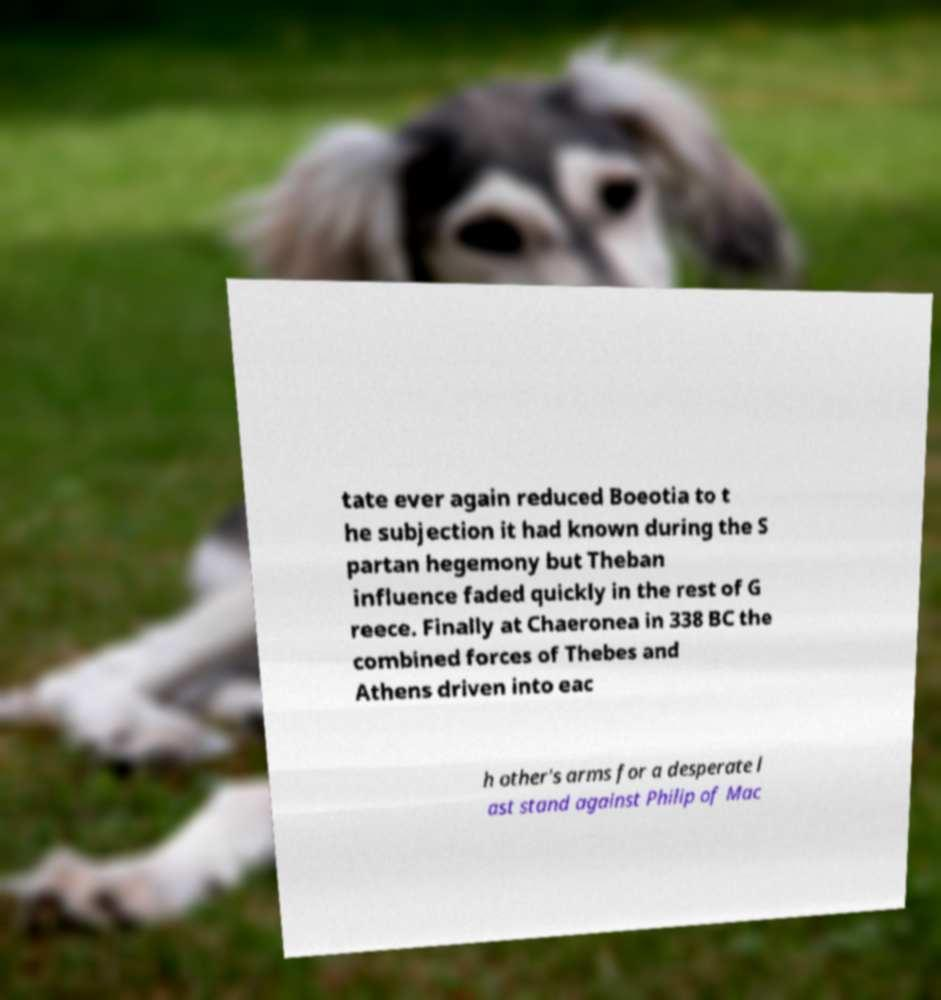Can you accurately transcribe the text from the provided image for me? tate ever again reduced Boeotia to t he subjection it had known during the S partan hegemony but Theban influence faded quickly in the rest of G reece. Finally at Chaeronea in 338 BC the combined forces of Thebes and Athens driven into eac h other's arms for a desperate l ast stand against Philip of Mac 